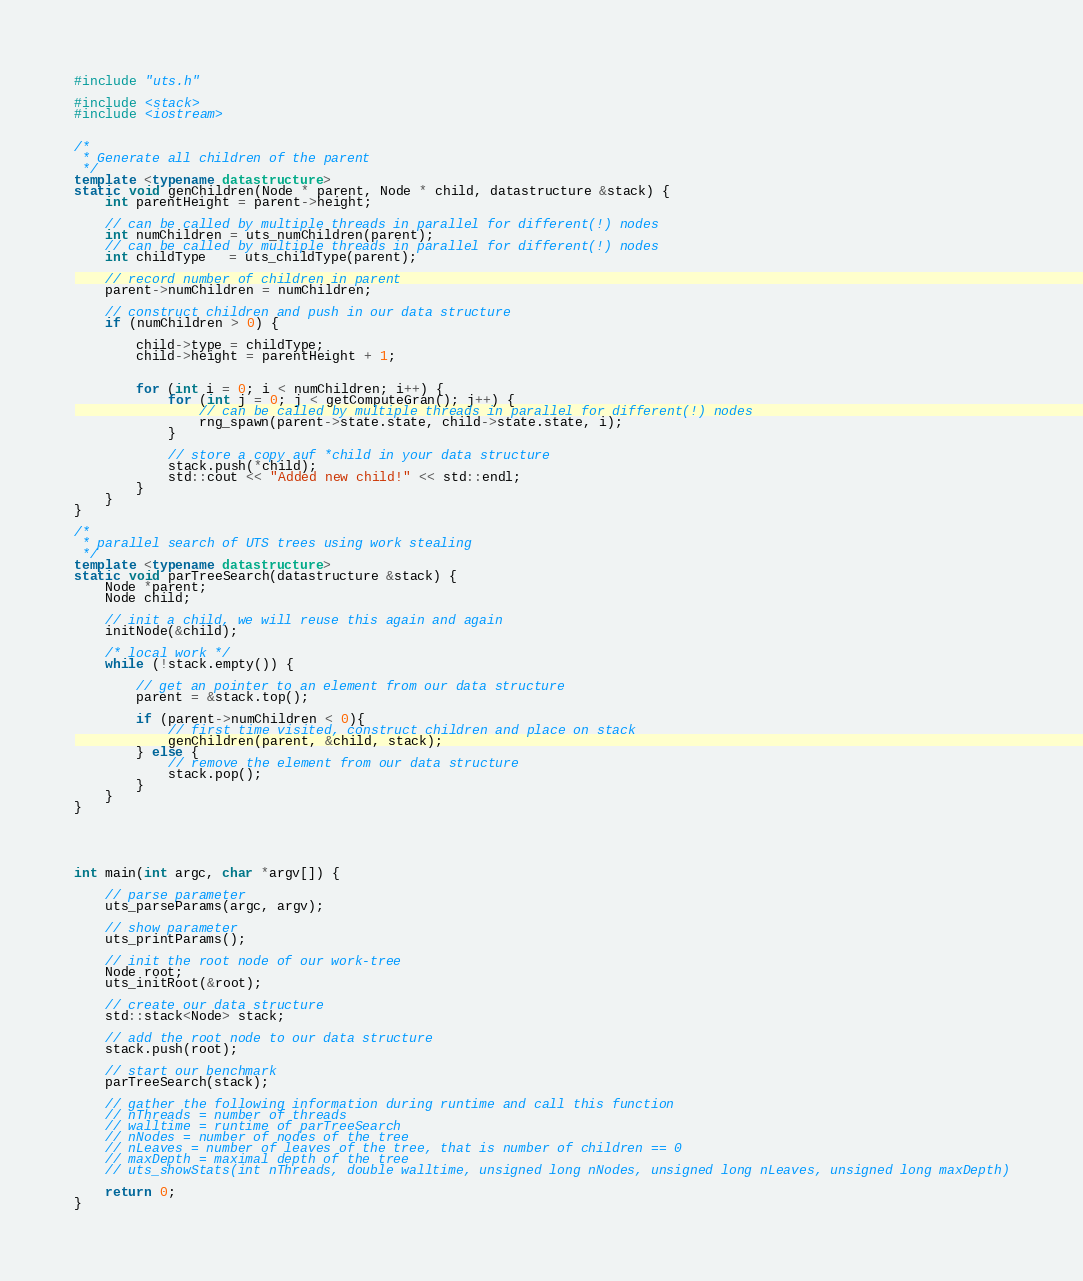Convert code to text. <code><loc_0><loc_0><loc_500><loc_500><_C++_>#include "uts.h"

#include <stack>
#include <iostream>


/* 
 * Generate all children of the parent
 */
template <typename datastructure>
static void genChildren(Node * parent, Node * child, datastructure &stack) {
	int parentHeight = parent->height;

	// can be called by multiple threads in parallel for different(!) nodes
	int numChildren = uts_numChildren(parent);
	// can be called by multiple threads in parallel for different(!) nodes
	int childType   = uts_childType(parent);

	// record number of children in parent
	parent->numChildren = numChildren;

	// construct children and push in our data structure
	if (numChildren > 0) {

		child->type = childType;
		child->height = parentHeight + 1;


		for (int i = 0; i < numChildren; i++) {
			for (int j = 0; j < getComputeGran(); j++) {
				// can be called by multiple threads in parallel for different(!) nodes
				rng_spawn(parent->state.state, child->state.state, i);
			}

			// store a copy auf *child in your data structure
			stack.push(*child);
			std::cout << "Added new child!" << std::endl;
		}
	}
}

/* 
 * parallel search of UTS trees using work stealing 
 */
template <typename datastructure>
static void parTreeSearch(datastructure &stack) {
	Node *parent;
	Node child;

	// init a child, we will reuse this again and again
	initNode(&child);

	/* local work */
	while (!stack.empty()) {

		// get an pointer to an element from our data structure
		parent = &stack.top();

		if (parent->numChildren < 0){
			// first time visited, construct children and place on stack
			genChildren(parent, &child, stack);
		} else {		
			// remove the element from our data structure
			stack.pop();
		}
	}
}





int main(int argc, char *argv[]) {

	// parse parameter
	uts_parseParams(argc, argv);
	
	// show parameter
	uts_printParams();

	// init the root node of our work-tree
	Node root;
	uts_initRoot(&root);
	
	// create our data structure
	std::stack<Node> stack;
	
	// add the root node to our data structure
	stack.push(root);

	// start our benchmark
	parTreeSearch(stack);

	// gather the following information during runtime and call this function
	// nThreads = number of threads
	// walltime = runtime of parTreeSearch
	// nNodes = number of nodes of the tree
	// nLeaves = number of leaves of the tree, that is number of children == 0
	// maxDepth = maximal depth of the tree
	// uts_showStats(int nThreads, double walltime, unsigned long nNodes, unsigned long nLeaves, unsigned long maxDepth)
	
	return 0;
}
</code> 